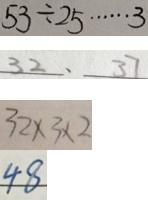Convert formula to latex. <formula><loc_0><loc_0><loc_500><loc_500>5 3 \div 2 5 \cdots 3 
 3 2 、 3 7 
 3 2 \times 3 \times 2 
 4 8</formula> 